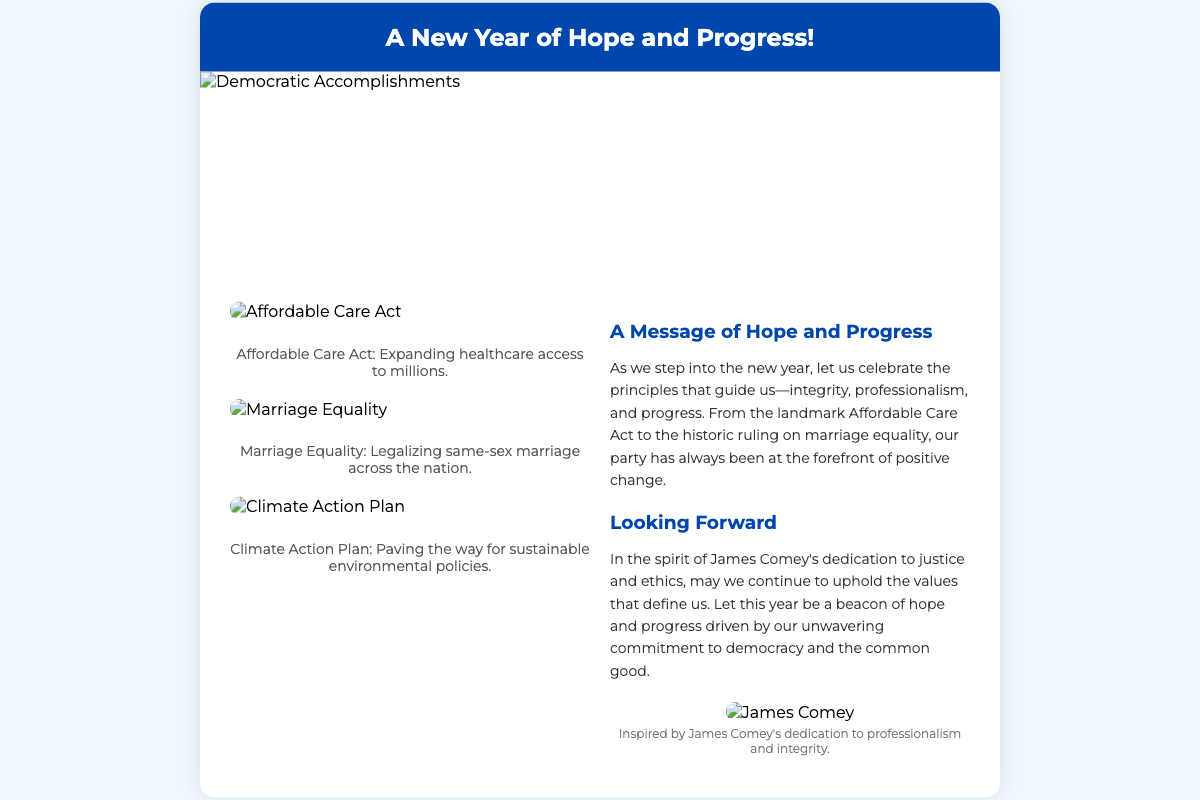What is the title of the card? The title is prominently displayed at the top of the card, reading "A New Year of Hope and Progress!"
Answer: A New Year of Hope and Progress! What major healthcare legislation is mentioned? The document includes a specific reference to the Affordable Care Act as a significant achievement.
Answer: Affordable Care Act What image represents the ruling on marriage equality? There is an image specifically labeled as "Marriage Equality" that depicts the legalizing of same-sex marriage.
Answer: Marriage Equality How many accomplishments are illustrated on the left side? The left side contains illustrations of three different accomplishments related to Democratic successes.
Answer: Three What values does the message emphasize? The message discusses integrity, professionalism, and progress as key values guiding the party.
Answer: Integrity, professionalism, progress Who is referenced as a source of inspiration in the card? The card specifically mentions James Comey as an individual whose dedication to ethics serves as inspiration.
Answer: James Comey What color is the card header? The card header is described as having a background color of #0047AB, which visually stands out.
Answer: Blue What is the main theme of the "Looking Forward" section? This section reflects on continuing to uphold values and emphasizes hope and progress for the upcoming year.
Answer: Hope and progress What type of card is this document classified as? The structure and purpose of the document classify it as a greeting card celebrating a new year.
Answer: Greeting card 